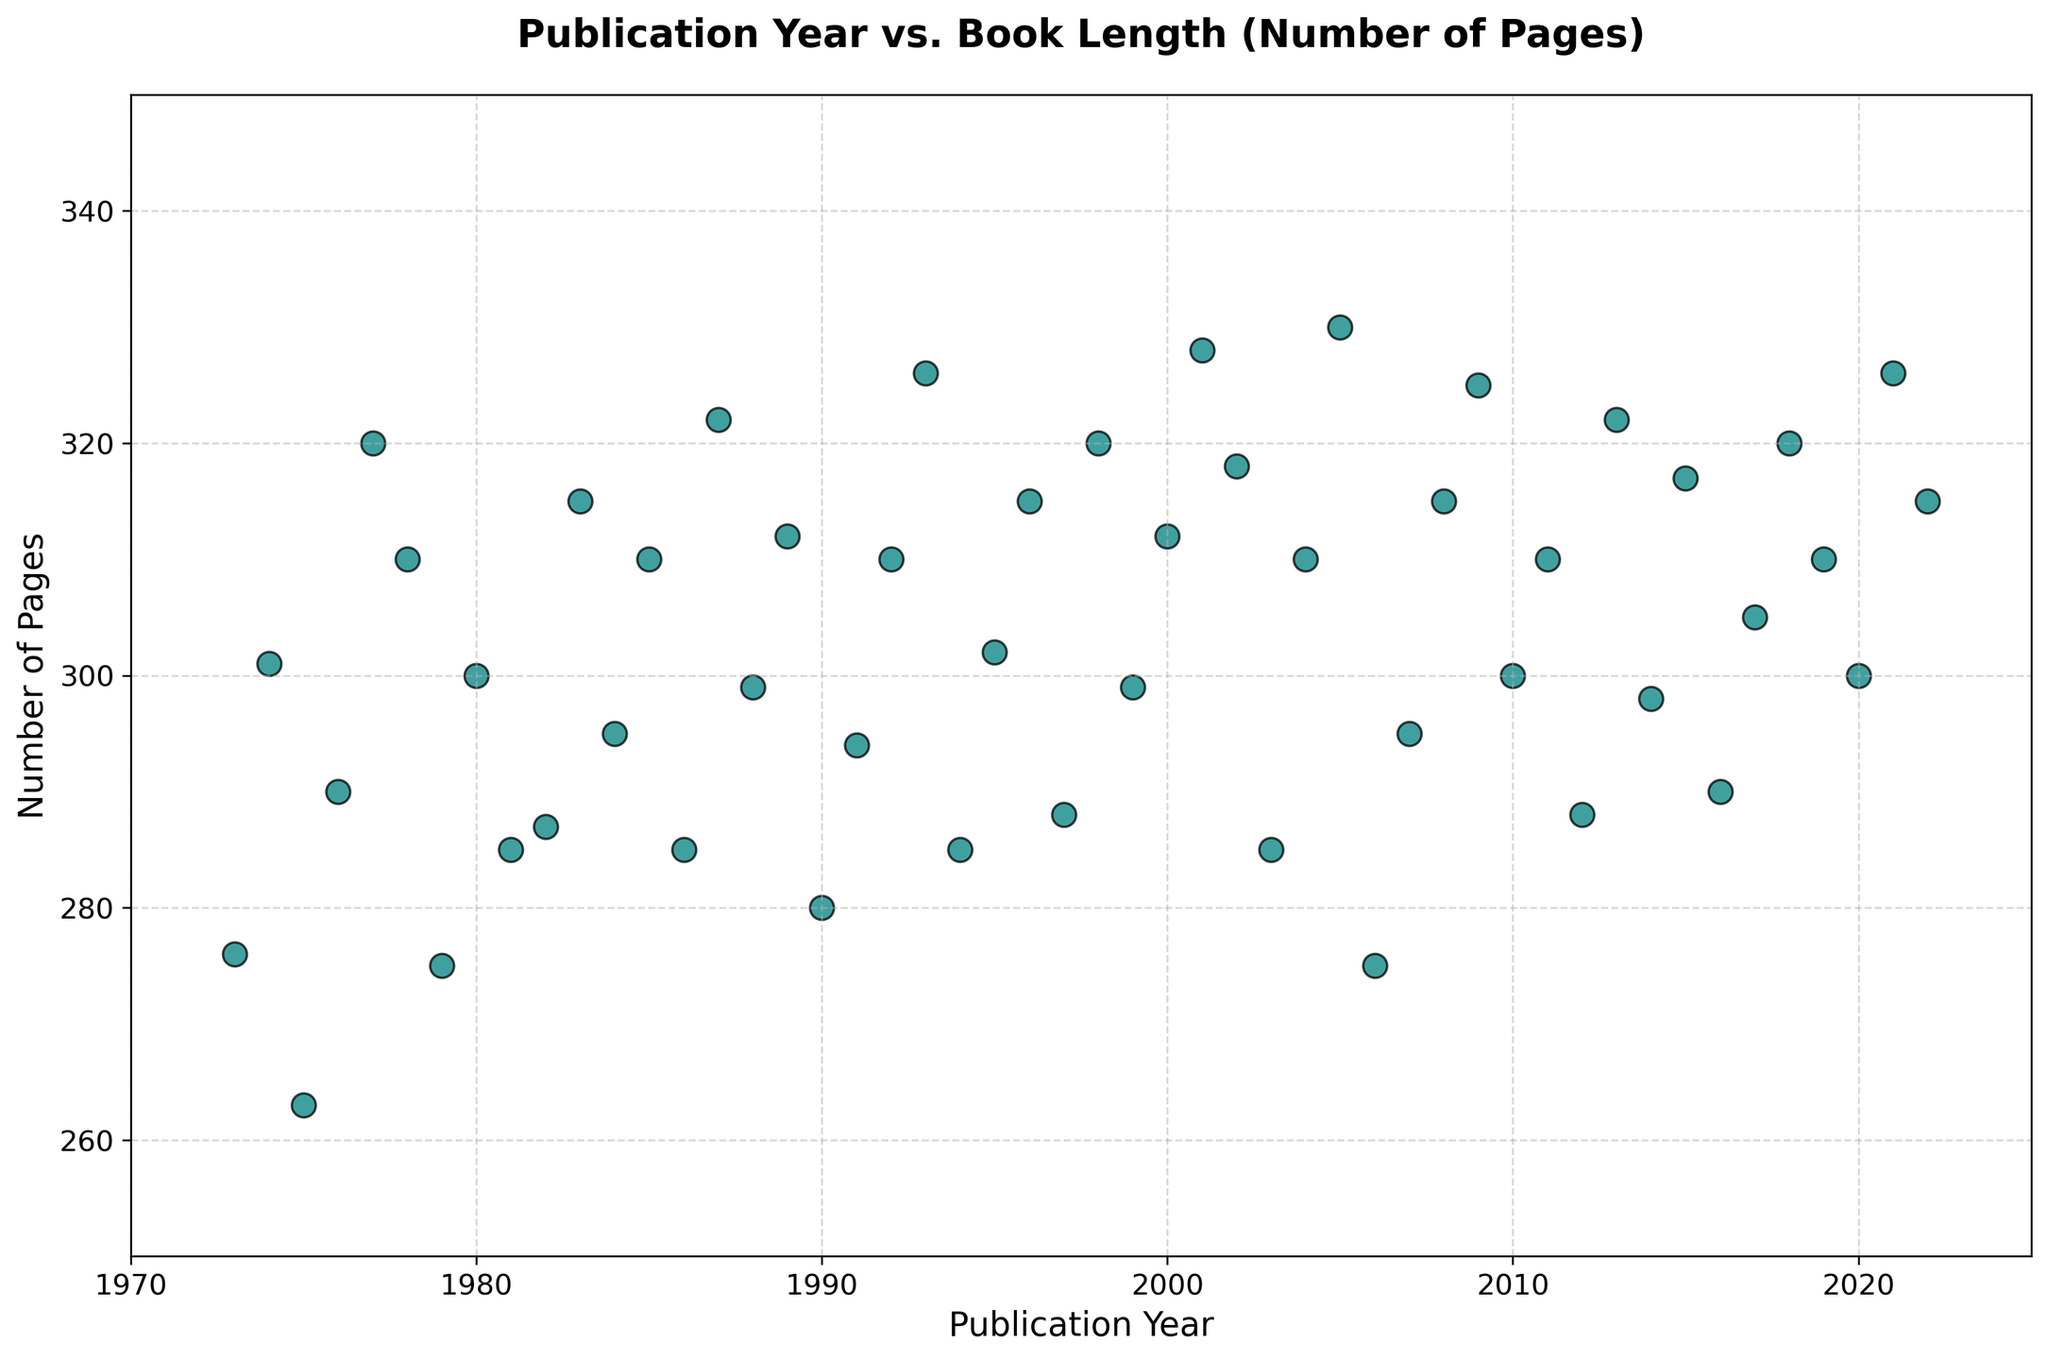What is the range of book lengths in the data? The shortest book in the data has 263 pages (from 1975), and the longest book has 330 pages (from 2005). Hence, the range is 330 - 263 = 67 pages.
Answer: 67 Is there a general trend in the length of books over the years? Observing the scatter plot, the book lengths generally increase over the years. Starting in the early '70s with lower values and increasing through recent years where lengths are higher. The overall trend appears to be an increase in book length over time.
Answer: Increasing Which year had the longest book, and how many pages did it have? The year 2005 had the longest book with 330 pages, as seen in the plot where the highest point corresponds to the year 2005.
Answer: 2005, 330 pages How does the book length in 1985 compare to the book length in 2000? The book length in 1985 is 310 pages, while the book length in 2000 is 312 pages. Therefore, the book in 2000 is 2 pages longer than that in 1985.
Answer: 2 pages longer in 2000 What is the average book length across all years in the dataset? Sum the pages of all books over the years, then divide by the number of years. Summing the pages yields 14,600, and there are 50 data points, so the average is 14,600 / 50 = 292 pages.
Answer: 292 pages Compare the book lengths in 1987 and 2012. Which year had the longer book, and by how many pages? The book length in 1987 is 322 pages and in 2012 is 288 pages. The year 1987 had a longer book by 322 - 288 = 34 pages.
Answer: 1987 by 34 pages What can be said about the spread of book lengths from 1999 to 2009? The book lengths from 1999 to 2009 range from 299 pages to 325 pages. The spread is relatively narrow compared to the overall range, indicating a more consistent length in this decade.
Answer: Narrow spread, 299 to 325 pages Identify any outliers in the dataset. Outliers are values significantly different from others. The most noticeable is the book in 2005 with 330 pages, as it stands out above other points. The book in 1975 with 263 pages is also an outlier at the lower end.
Answer: 2005 (330 pages), 1975 (263 pages) 